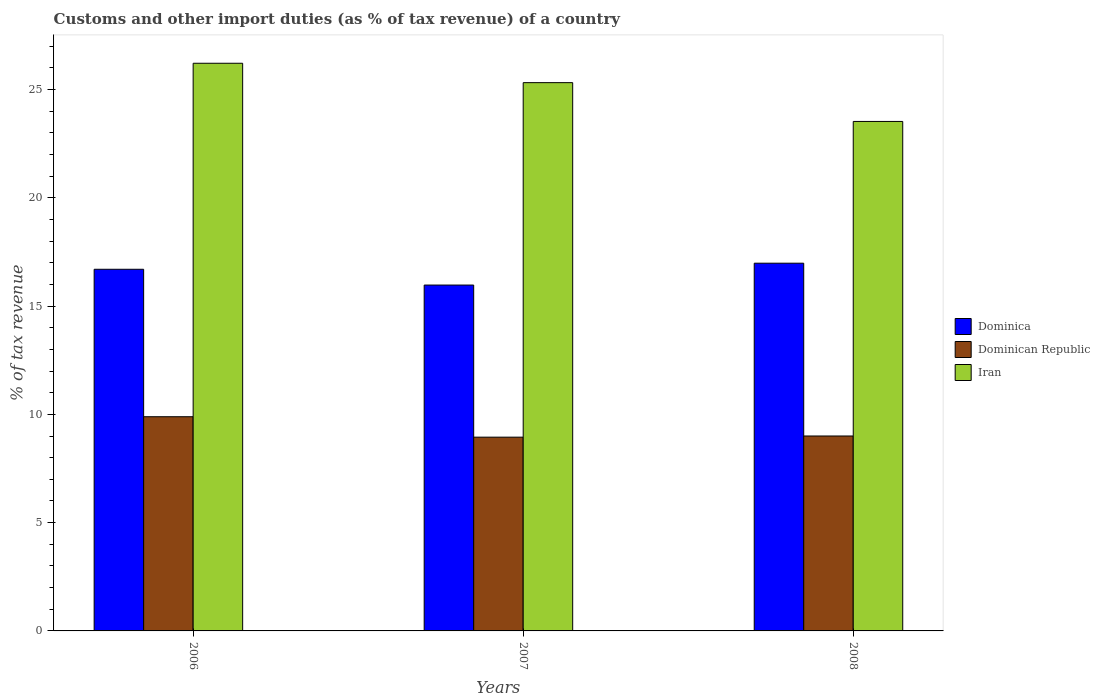How many different coloured bars are there?
Offer a terse response. 3. How many groups of bars are there?
Make the answer very short. 3. Are the number of bars on each tick of the X-axis equal?
Your answer should be very brief. Yes. How many bars are there on the 3rd tick from the right?
Keep it short and to the point. 3. What is the label of the 2nd group of bars from the left?
Your response must be concise. 2007. What is the percentage of tax revenue from customs in Dominican Republic in 2006?
Your response must be concise. 9.89. Across all years, what is the maximum percentage of tax revenue from customs in Dominica?
Offer a terse response. 16.98. Across all years, what is the minimum percentage of tax revenue from customs in Dominican Republic?
Offer a very short reply. 8.95. In which year was the percentage of tax revenue from customs in Dominican Republic maximum?
Give a very brief answer. 2006. In which year was the percentage of tax revenue from customs in Iran minimum?
Make the answer very short. 2008. What is the total percentage of tax revenue from customs in Dominican Republic in the graph?
Your response must be concise. 27.84. What is the difference between the percentage of tax revenue from customs in Dominica in 2006 and that in 2007?
Make the answer very short. 0.73. What is the difference between the percentage of tax revenue from customs in Dominican Republic in 2007 and the percentage of tax revenue from customs in Dominica in 2006?
Give a very brief answer. -7.75. What is the average percentage of tax revenue from customs in Dominican Republic per year?
Make the answer very short. 9.28. In the year 2006, what is the difference between the percentage of tax revenue from customs in Dominican Republic and percentage of tax revenue from customs in Iran?
Your response must be concise. -16.32. In how many years, is the percentage of tax revenue from customs in Dominica greater than 3 %?
Offer a terse response. 3. What is the ratio of the percentage of tax revenue from customs in Dominica in 2007 to that in 2008?
Make the answer very short. 0.94. What is the difference between the highest and the second highest percentage of tax revenue from customs in Dominica?
Your response must be concise. 0.28. What is the difference between the highest and the lowest percentage of tax revenue from customs in Dominican Republic?
Make the answer very short. 0.94. What does the 3rd bar from the left in 2006 represents?
Give a very brief answer. Iran. What does the 2nd bar from the right in 2007 represents?
Give a very brief answer. Dominican Republic. How many bars are there?
Give a very brief answer. 9. Are all the bars in the graph horizontal?
Offer a terse response. No. What is the difference between two consecutive major ticks on the Y-axis?
Provide a short and direct response. 5. Are the values on the major ticks of Y-axis written in scientific E-notation?
Your answer should be compact. No. Does the graph contain any zero values?
Offer a very short reply. No. How many legend labels are there?
Offer a terse response. 3. How are the legend labels stacked?
Your response must be concise. Vertical. What is the title of the graph?
Provide a short and direct response. Customs and other import duties (as % of tax revenue) of a country. What is the label or title of the X-axis?
Provide a succinct answer. Years. What is the label or title of the Y-axis?
Make the answer very short. % of tax revenue. What is the % of tax revenue in Dominica in 2006?
Your answer should be very brief. 16.7. What is the % of tax revenue in Dominican Republic in 2006?
Ensure brevity in your answer.  9.89. What is the % of tax revenue of Iran in 2006?
Your answer should be compact. 26.21. What is the % of tax revenue in Dominica in 2007?
Give a very brief answer. 15.97. What is the % of tax revenue in Dominican Republic in 2007?
Offer a very short reply. 8.95. What is the % of tax revenue in Iran in 2007?
Provide a succinct answer. 25.32. What is the % of tax revenue of Dominica in 2008?
Give a very brief answer. 16.98. What is the % of tax revenue of Dominican Republic in 2008?
Provide a short and direct response. 9. What is the % of tax revenue of Iran in 2008?
Provide a short and direct response. 23.53. Across all years, what is the maximum % of tax revenue of Dominica?
Your response must be concise. 16.98. Across all years, what is the maximum % of tax revenue in Dominican Republic?
Offer a very short reply. 9.89. Across all years, what is the maximum % of tax revenue of Iran?
Your answer should be very brief. 26.21. Across all years, what is the minimum % of tax revenue in Dominica?
Ensure brevity in your answer.  15.97. Across all years, what is the minimum % of tax revenue of Dominican Republic?
Your answer should be compact. 8.95. Across all years, what is the minimum % of tax revenue in Iran?
Your response must be concise. 23.53. What is the total % of tax revenue in Dominica in the graph?
Keep it short and to the point. 49.65. What is the total % of tax revenue of Dominican Republic in the graph?
Your response must be concise. 27.84. What is the total % of tax revenue of Iran in the graph?
Ensure brevity in your answer.  75.06. What is the difference between the % of tax revenue of Dominica in 2006 and that in 2007?
Your answer should be very brief. 0.73. What is the difference between the % of tax revenue of Dominican Republic in 2006 and that in 2007?
Provide a succinct answer. 0.94. What is the difference between the % of tax revenue in Iran in 2006 and that in 2007?
Your answer should be very brief. 0.9. What is the difference between the % of tax revenue of Dominica in 2006 and that in 2008?
Give a very brief answer. -0.28. What is the difference between the % of tax revenue in Dominican Republic in 2006 and that in 2008?
Give a very brief answer. 0.89. What is the difference between the % of tax revenue in Iran in 2006 and that in 2008?
Offer a very short reply. 2.69. What is the difference between the % of tax revenue of Dominica in 2007 and that in 2008?
Ensure brevity in your answer.  -1.01. What is the difference between the % of tax revenue in Dominican Republic in 2007 and that in 2008?
Offer a very short reply. -0.05. What is the difference between the % of tax revenue of Iran in 2007 and that in 2008?
Give a very brief answer. 1.79. What is the difference between the % of tax revenue of Dominica in 2006 and the % of tax revenue of Dominican Republic in 2007?
Give a very brief answer. 7.75. What is the difference between the % of tax revenue of Dominica in 2006 and the % of tax revenue of Iran in 2007?
Make the answer very short. -8.62. What is the difference between the % of tax revenue in Dominican Republic in 2006 and the % of tax revenue in Iran in 2007?
Your answer should be compact. -15.43. What is the difference between the % of tax revenue of Dominica in 2006 and the % of tax revenue of Dominican Republic in 2008?
Make the answer very short. 7.7. What is the difference between the % of tax revenue in Dominica in 2006 and the % of tax revenue in Iran in 2008?
Your answer should be very brief. -6.83. What is the difference between the % of tax revenue in Dominican Republic in 2006 and the % of tax revenue in Iran in 2008?
Offer a terse response. -13.64. What is the difference between the % of tax revenue in Dominica in 2007 and the % of tax revenue in Dominican Republic in 2008?
Offer a terse response. 6.97. What is the difference between the % of tax revenue in Dominica in 2007 and the % of tax revenue in Iran in 2008?
Make the answer very short. -7.55. What is the difference between the % of tax revenue of Dominican Republic in 2007 and the % of tax revenue of Iran in 2008?
Your response must be concise. -14.58. What is the average % of tax revenue of Dominica per year?
Provide a succinct answer. 16.55. What is the average % of tax revenue of Dominican Republic per year?
Your answer should be compact. 9.28. What is the average % of tax revenue of Iran per year?
Your answer should be compact. 25.02. In the year 2006, what is the difference between the % of tax revenue in Dominica and % of tax revenue in Dominican Republic?
Provide a short and direct response. 6.81. In the year 2006, what is the difference between the % of tax revenue in Dominica and % of tax revenue in Iran?
Offer a very short reply. -9.51. In the year 2006, what is the difference between the % of tax revenue in Dominican Republic and % of tax revenue in Iran?
Offer a terse response. -16.32. In the year 2007, what is the difference between the % of tax revenue of Dominica and % of tax revenue of Dominican Republic?
Provide a succinct answer. 7.02. In the year 2007, what is the difference between the % of tax revenue of Dominica and % of tax revenue of Iran?
Your answer should be very brief. -9.35. In the year 2007, what is the difference between the % of tax revenue in Dominican Republic and % of tax revenue in Iran?
Offer a very short reply. -16.37. In the year 2008, what is the difference between the % of tax revenue in Dominica and % of tax revenue in Dominican Republic?
Provide a short and direct response. 7.98. In the year 2008, what is the difference between the % of tax revenue of Dominica and % of tax revenue of Iran?
Offer a very short reply. -6.55. In the year 2008, what is the difference between the % of tax revenue in Dominican Republic and % of tax revenue in Iran?
Provide a short and direct response. -14.53. What is the ratio of the % of tax revenue in Dominica in 2006 to that in 2007?
Your response must be concise. 1.05. What is the ratio of the % of tax revenue in Dominican Republic in 2006 to that in 2007?
Offer a terse response. 1.11. What is the ratio of the % of tax revenue of Iran in 2006 to that in 2007?
Keep it short and to the point. 1.04. What is the ratio of the % of tax revenue in Dominica in 2006 to that in 2008?
Keep it short and to the point. 0.98. What is the ratio of the % of tax revenue in Dominican Republic in 2006 to that in 2008?
Make the answer very short. 1.1. What is the ratio of the % of tax revenue of Iran in 2006 to that in 2008?
Provide a short and direct response. 1.11. What is the ratio of the % of tax revenue in Dominica in 2007 to that in 2008?
Provide a succinct answer. 0.94. What is the ratio of the % of tax revenue in Dominican Republic in 2007 to that in 2008?
Offer a terse response. 0.99. What is the ratio of the % of tax revenue in Iran in 2007 to that in 2008?
Keep it short and to the point. 1.08. What is the difference between the highest and the second highest % of tax revenue in Dominica?
Provide a succinct answer. 0.28. What is the difference between the highest and the second highest % of tax revenue of Dominican Republic?
Your answer should be compact. 0.89. What is the difference between the highest and the second highest % of tax revenue of Iran?
Your response must be concise. 0.9. What is the difference between the highest and the lowest % of tax revenue in Dominica?
Provide a short and direct response. 1.01. What is the difference between the highest and the lowest % of tax revenue in Dominican Republic?
Make the answer very short. 0.94. What is the difference between the highest and the lowest % of tax revenue of Iran?
Give a very brief answer. 2.69. 